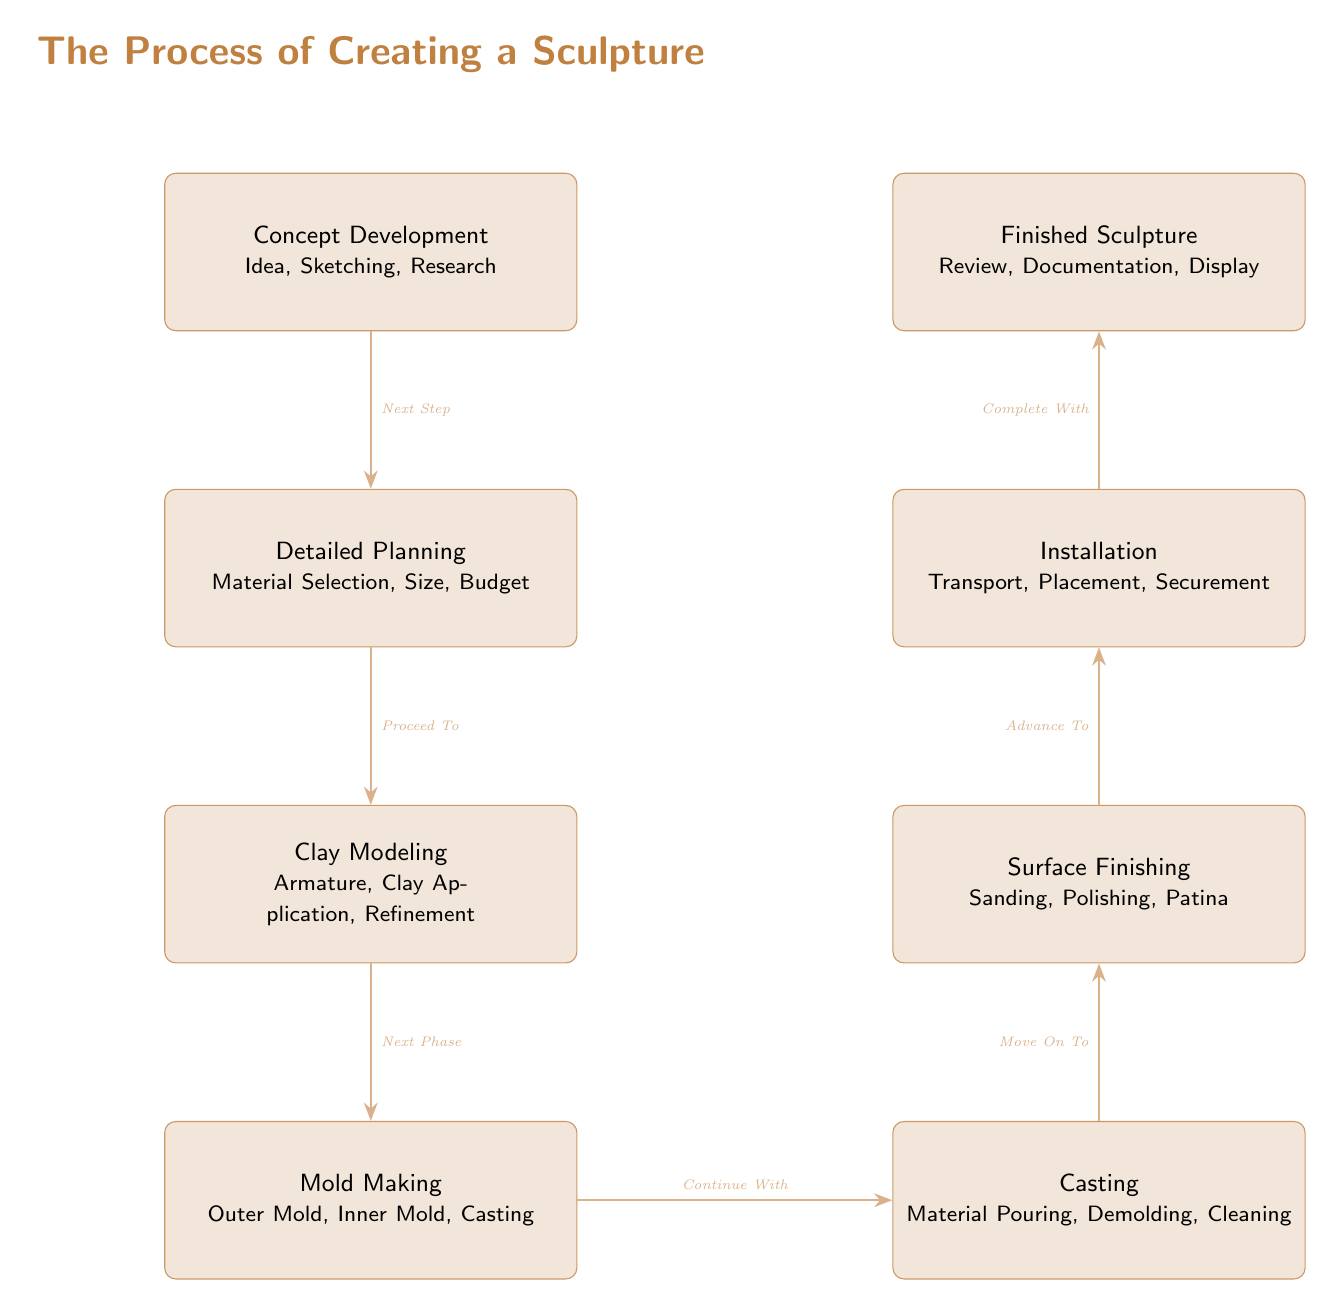What is the first step in the sculpture creation process? The diagram clearly indicates that the first step is "Concept Development," which is placed at the top of the flowchart.
Answer: Concept Development How many main steps are there in the process? By counting the boxes in the diagram, there are eight main steps listed from "Concept Development" down to "Finished Sculpture."
Answer: 8 What is the last step before the finished sculpture? The last step before reaching "Finished Sculpture" is "Installation." It is positioned directly above the final product in the diagram.
Answer: Installation Which step involves creating a mold? The step that involves making a mold is "Mold Making." This includes processes like creating both outer and inner molds.
Answer: Mold Making What comes after clay modeling? Referring to the arrows indicating the flow, "Mold Making" is the step that follows "Clay Modeling." The diagram shows a clear directional arrow leading down from clay modeling to mold making.
Answer: Mold Making What is involved in the "Surface Finishing" step? The "Surface Finishing" step includes processes described in the box, specifically "Sanding, Polishing, Patina." This is detailed in the text within that specific node.
Answer: Sanding, Polishing, Patina Which two steps are connected by an arrow labeled "Complete With"? The steps connected by the arrow labeled "Complete With" are "Installation" leading directly to "Finished Sculpture." The label clearly indicates to proceed from installation to the final product.
Answer: Installation, Finished Sculpture Identify the phase right after "Casting." Following "Casting," the next phase as indicated in the diagram is "Surface Finishing." This is depicted by the arrow pointing from casting to finishing.
Answer: Surface Finishing 